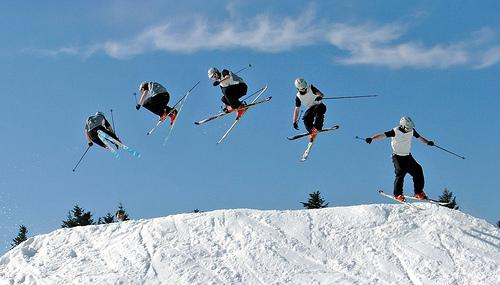Question: what is the weather like?
Choices:
A. Snowy.
B. Hurricane.
C. Windy.
D. Clear and sunny.
Answer with the letter. Answer: D Question: what are these men doing?
Choices:
A. Skiing.
B. Walking.
C. Eating.
D. Biking.
Answer with the letter. Answer: A Question: who are these men?
Choices:
A. The CIA.
B. Skiers.
C. The police.
D. The firm.
Answer with the letter. Answer: B Question: what is on the ground?
Choices:
A. Snow.
B. Grass.
C. Sand.
D. Dirt.
Answer with the letter. Answer: A 